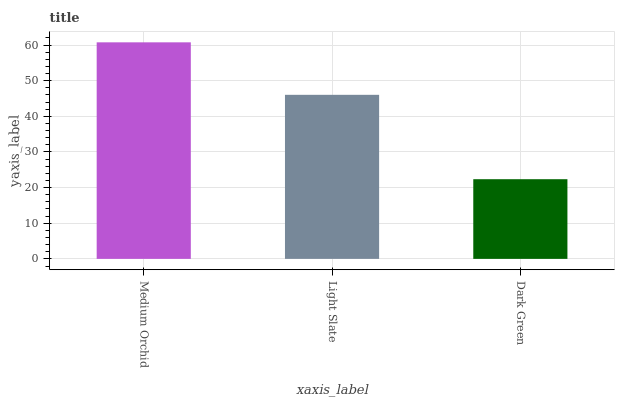Is Dark Green the minimum?
Answer yes or no. Yes. Is Medium Orchid the maximum?
Answer yes or no. Yes. Is Light Slate the minimum?
Answer yes or no. No. Is Light Slate the maximum?
Answer yes or no. No. Is Medium Orchid greater than Light Slate?
Answer yes or no. Yes. Is Light Slate less than Medium Orchid?
Answer yes or no. Yes. Is Light Slate greater than Medium Orchid?
Answer yes or no. No. Is Medium Orchid less than Light Slate?
Answer yes or no. No. Is Light Slate the high median?
Answer yes or no. Yes. Is Light Slate the low median?
Answer yes or no. Yes. Is Medium Orchid the high median?
Answer yes or no. No. Is Medium Orchid the low median?
Answer yes or no. No. 